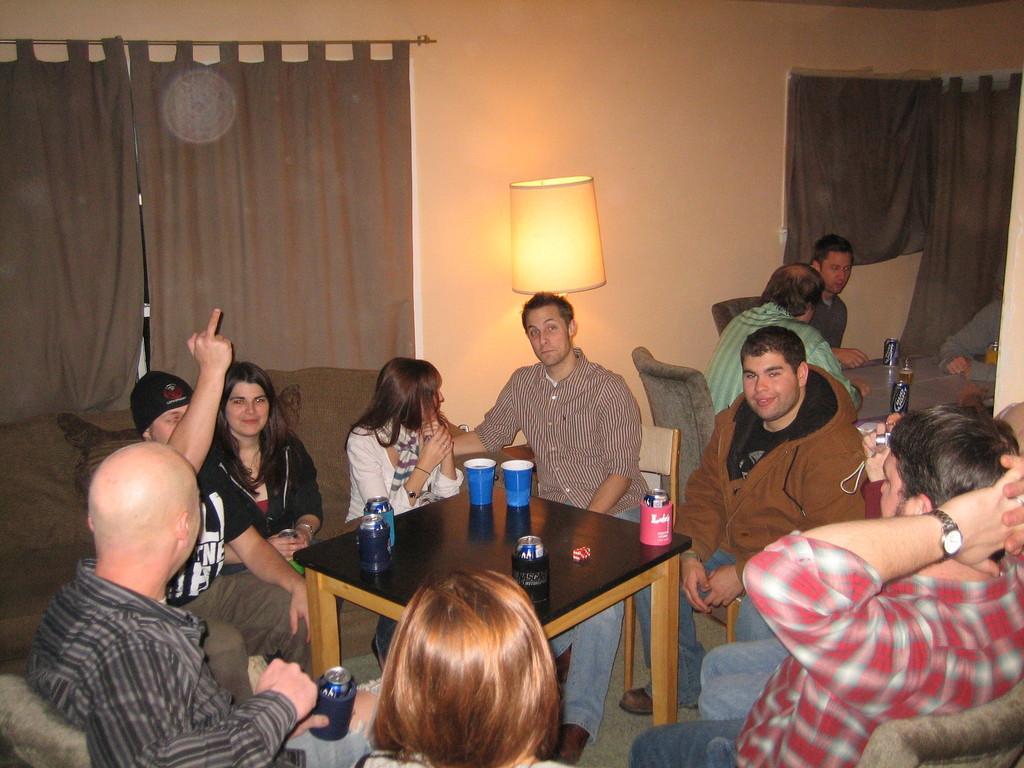Please provide a concise description of this image. In this image i can see group of people sitting there are two glasses, bottle on a table at the back ground i can see few other people sitting and few bottles on the table, a lamp, a curtain and a wall. 